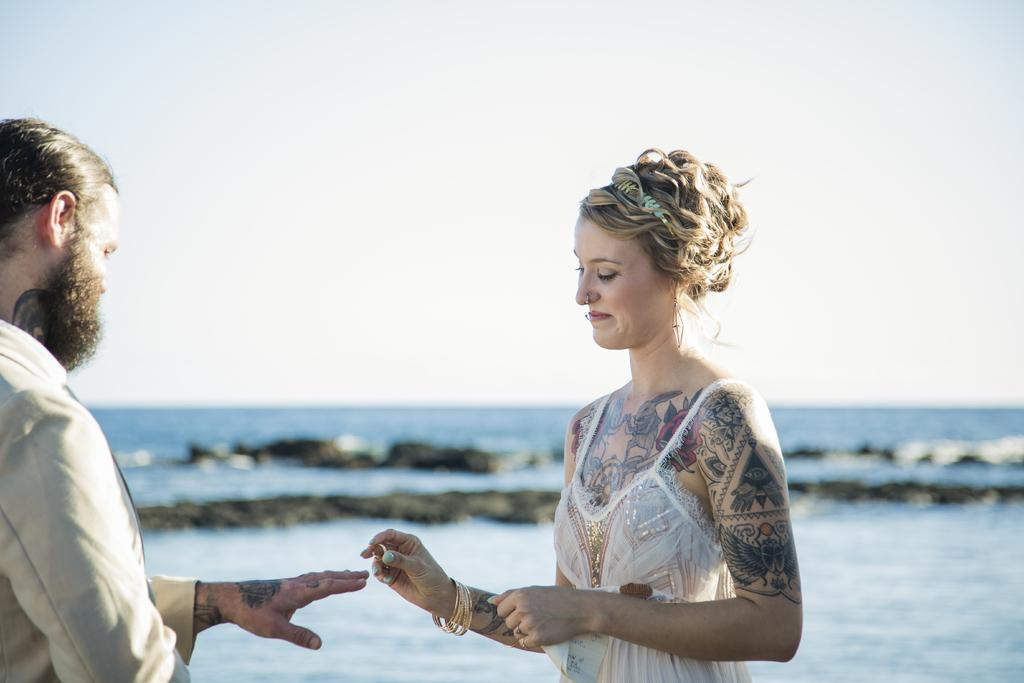How many people are present in the image? There are two persons in the image. What is the woman holding in her hand? The woman is holding a ring in her hand. What can be seen in the background of the image? There is water, rocks, and the sky visible in the background of the image. What type of farm animals can be seen in the image? There are no farm animals present in the image. How does the woman plan to stitch the ring in the image? The image does not show the woman stitching anything, nor is there any indication that she plans to do so. 